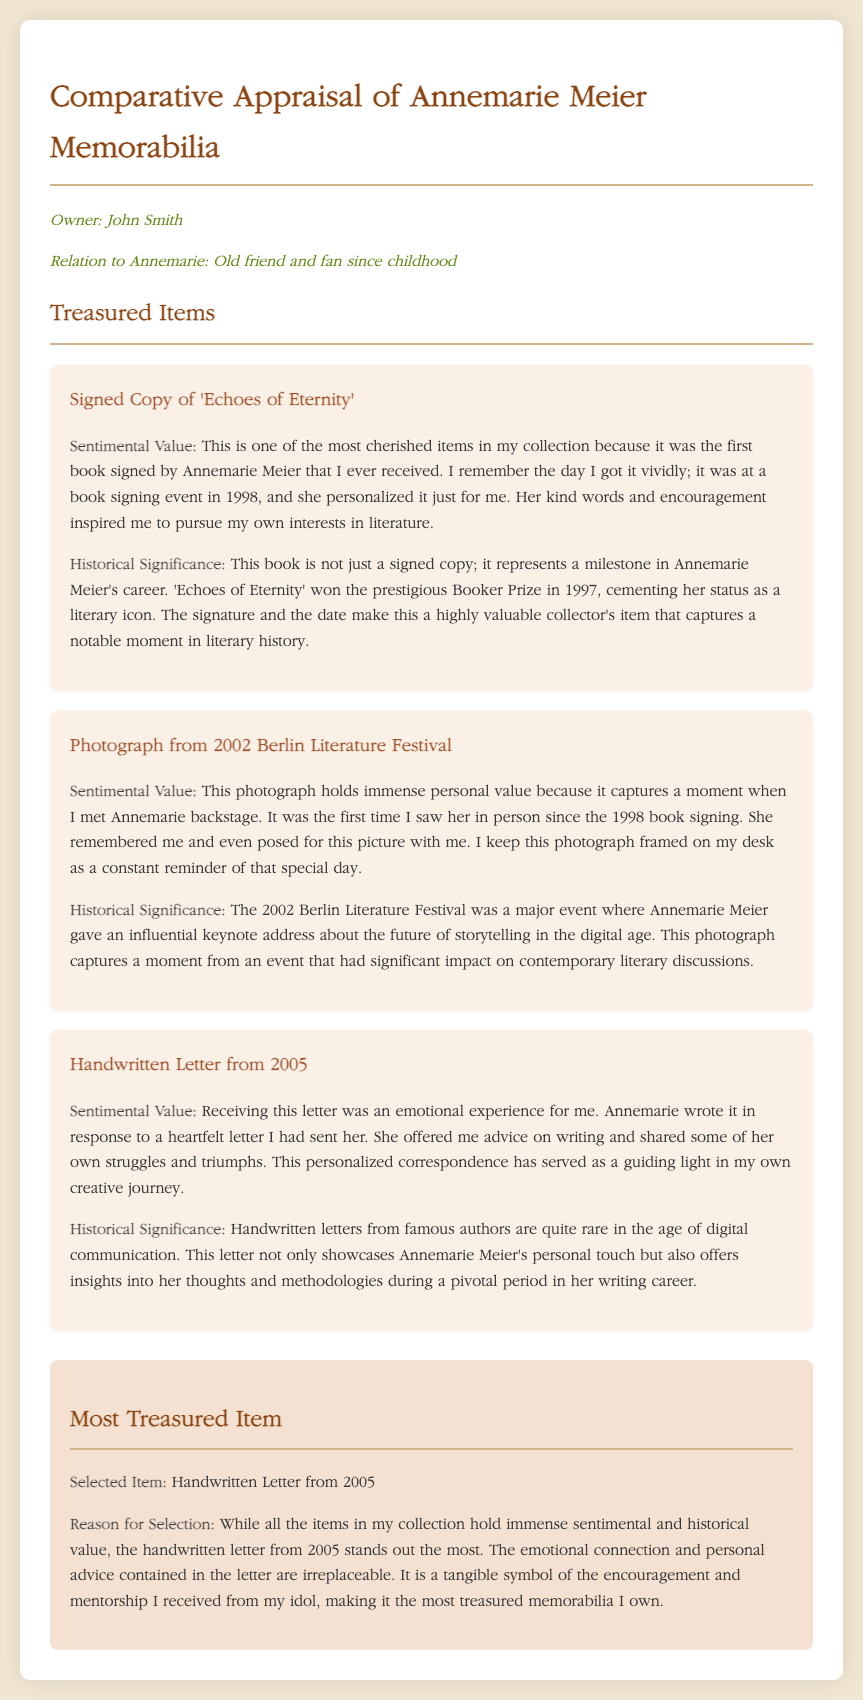What is the owner's name? The owner's name is stated at the top of the document in the owner info section.
Answer: John Smith What was the title of the signed book? The document lists the title of the signed book in the first item description.
Answer: Echoes of Eternity In what year did the book signing event occur? The year of the book signing event is mentioned in the description of the signed book.
Answer: 1998 What is the date on the handwritten letter? The handwritten letter is dated in the description of the item focusing on it.
Answer: 2005 What major event is highlighted in connection with the photograph? The document mentions a specific event related to the photograph in its description.
Answer: Berlin Literature Festival Why was the handwritten letter selected as the most treasured item? The reasoning behind selecting the handwritten letter is discussed in the comparison section of the document.
Answer: Emotional connection and personal advice What prestigious award did 'Echoes of Eternity' win? The award is mentioned in the historical significance section of the signed copy description.
Answer: Booker Prize What year was the Berlin Literature Festival held? The event year is specified in the description of the photograph.
Answer: 2002 What does the owner keep the photograph framed on? The owner mentions where they keep this treasured photograph in its description.
Answer: Desk 